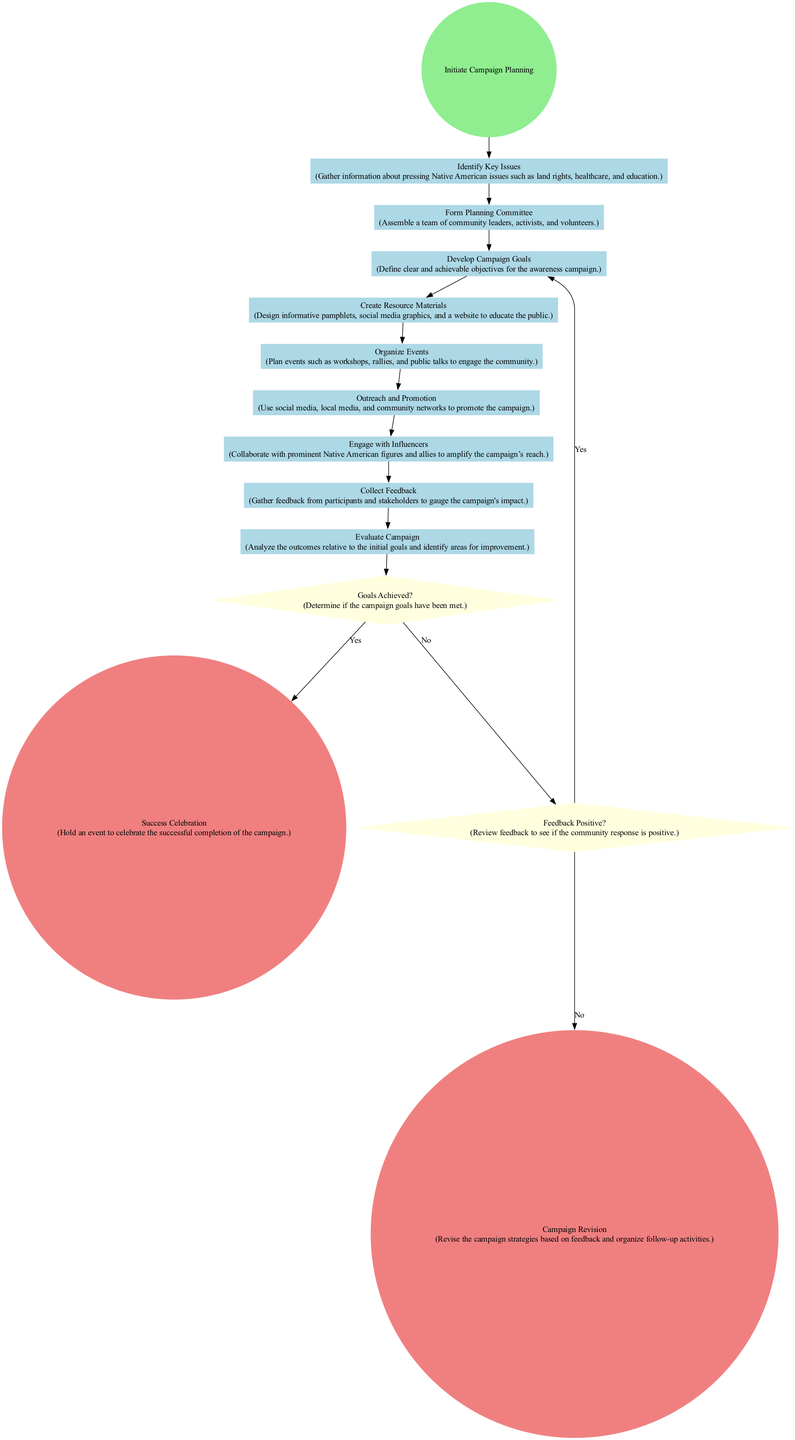What is the first activity in the diagram? The diagram starts from the "Initiate Campaign Planning" event, and the first activity listed afterwards is "Identify Key Issues."
Answer: Identify Key Issues How many activities are in the diagram? The diagram contains a total of nine activities ranging from "Identify Key Issues" to "Collect Feedback."
Answer: Nine What follows "Engage with Influencers" in the sequence? In the flow of the diagram, after "Engage with Influencers," the next activity is "Collect Feedback."
Answer: Collect Feedback What decision node assesses if campaign goals are achieved? The decision node that evaluates whether the campaign goals have been met is named "Goals Achieved?"
Answer: Goals Achieved? If the feedback is positive, what is the next step according to the flow? According to the flow, if the feedback is positive, it leads to the "Success Celebration" end event.
Answer: Success Celebration How many end events are present in the diagram? There are two end events marked in the diagram: "Success Celebration" and "Campaign Revision."
Answer: Two What happens if "Goals Achieved?" is answered with "No"? If "Goals Achieved?" is answered with "No," the flow moves to the next decision node "Feedback Positive?" for further assessment.
Answer: Feedback Positive? What is the main purpose of the "Create Resource Materials" activity? The purpose of "Create Resource Materials" is to design informative pamphlets, social media graphics, and a website to educate the public about the campaign.
Answer: Educate the public What action is taken before "Outreach and Promotion" in the diagram? Before "Outreach and Promotion," the preceding activity in the sequence is "Organize Events."
Answer: Organize Events 